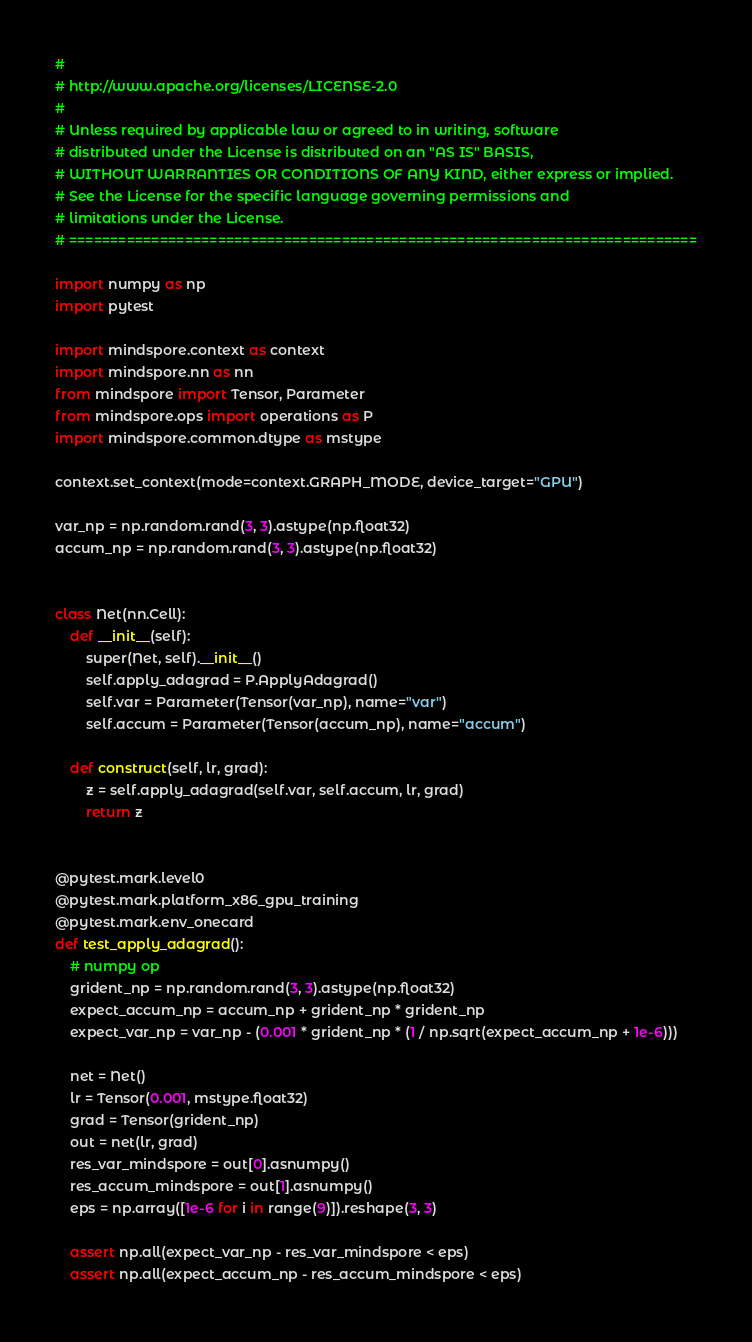<code> <loc_0><loc_0><loc_500><loc_500><_Python_>#
# http://www.apache.org/licenses/LICENSE-2.0
#
# Unless required by applicable law or agreed to in writing, software
# distributed under the License is distributed on an "AS IS" BASIS,
# WITHOUT WARRANTIES OR CONDITIONS OF ANY KIND, either express or implied.
# See the License for the specific language governing permissions and
# limitations under the License.
# ============================================================================

import numpy as np
import pytest

import mindspore.context as context
import mindspore.nn as nn
from mindspore import Tensor, Parameter
from mindspore.ops import operations as P
import mindspore.common.dtype as mstype

context.set_context(mode=context.GRAPH_MODE, device_target="GPU")

var_np = np.random.rand(3, 3).astype(np.float32)
accum_np = np.random.rand(3, 3).astype(np.float32)


class Net(nn.Cell):
    def __init__(self):
        super(Net, self).__init__()
        self.apply_adagrad = P.ApplyAdagrad()
        self.var = Parameter(Tensor(var_np), name="var")
        self.accum = Parameter(Tensor(accum_np), name="accum")

    def construct(self, lr, grad):
        z = self.apply_adagrad(self.var, self.accum, lr, grad)
        return z


@pytest.mark.level0
@pytest.mark.platform_x86_gpu_training
@pytest.mark.env_onecard
def test_apply_adagrad():
    # numpy op
    grident_np = np.random.rand(3, 3).astype(np.float32)
    expect_accum_np = accum_np + grident_np * grident_np
    expect_var_np = var_np - (0.001 * grident_np * (1 / np.sqrt(expect_accum_np + 1e-6)))

    net = Net()
    lr = Tensor(0.001, mstype.float32)
    grad = Tensor(grident_np)
    out = net(lr, grad)
    res_var_mindspore = out[0].asnumpy()
    res_accum_mindspore = out[1].asnumpy()
    eps = np.array([1e-6 for i in range(9)]).reshape(3, 3)

    assert np.all(expect_var_np - res_var_mindspore < eps)
    assert np.all(expect_accum_np - res_accum_mindspore < eps)
</code> 